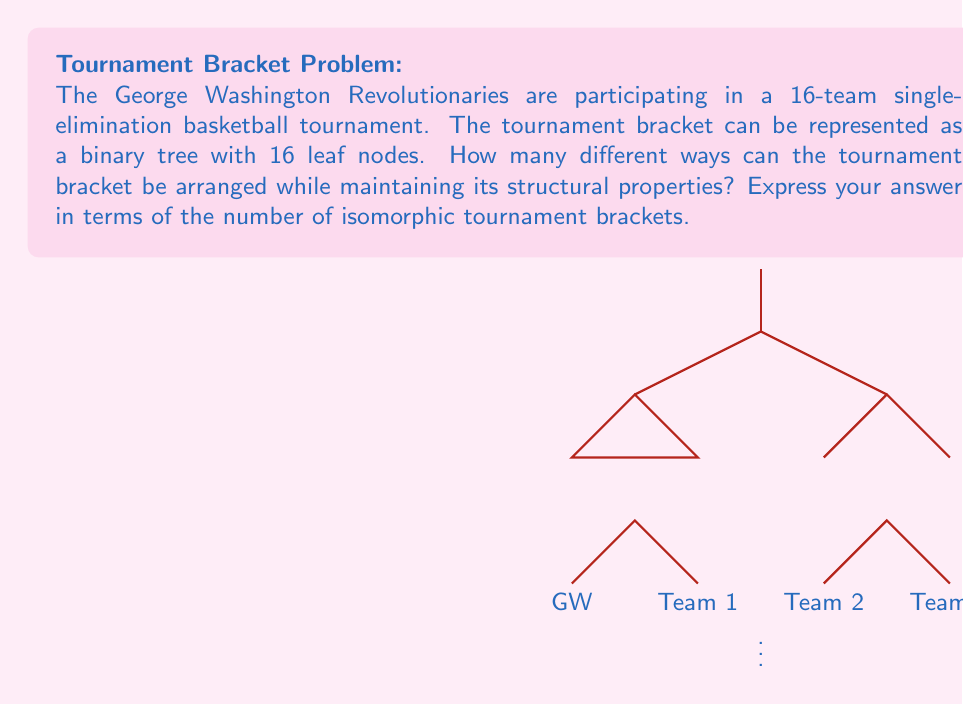What is the answer to this math problem? Let's approach this step-by-step:

1) First, we need to understand what it means for two tournament brackets to be isomorphic. Two brackets are isomorphic if they have the same structure, regardless of the specific teams assigned to each position.

2) In a single-elimination tournament with 16 teams, we have a binary tree with 4 levels (excluding the root).

3) At each non-leaf node, we have two choices: which subtree goes to the left and which goes to the right. This choice doesn't change the structure of the bracket, but it does create a visually different arrangement.

4) Let's count the number of these choices level by level:
   - At the root (final match): 1 choice
   - At the second level (semi-finals): 2 choices
   - At the third level (quarter-finals): 4 choices
   - At the fourth level (round of 16): 8 choices

5) The total number of arrangements is the product of these choices:

   $$1 \times 2 \times 4 \times 8 = 64$$

6) However, this counts every possible flip at every level. To get the number of isomorphic brackets, we need to consider that flipping both children of a node results in the same structure.

7) Therefore, we need to divide our total by 2 for each level (except the leaf level):

   $$64 \div (2 \times 2 \times 2) = 8$$

Thus, there are 8 different isomorphic tournament brackets for a 16-team single-elimination tournament.
Answer: 8 